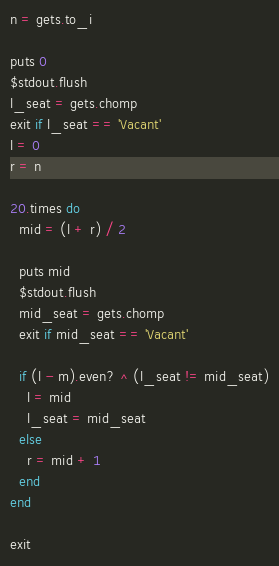Convert code to text. <code><loc_0><loc_0><loc_500><loc_500><_Ruby_>n = gets.to_i

puts 0
$stdout.flush
l_seat = gets.chomp
exit if l_seat == 'Vacant'
l = 0
r = n

20.times do
  mid = (l + r) / 2

  puts mid
  $stdout.flush
  mid_seat = gets.chomp
  exit if mid_seat == 'Vacant'

  if (l - m).even? ^ (l_seat != mid_seat)
    l = mid
    l_seat = mid_seat
  else
    r = mid + 1
  end
end

exit</code> 